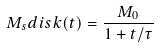Convert formula to latex. <formula><loc_0><loc_0><loc_500><loc_500>M _ { s } { d i s k } ( t ) = \frac { M _ { 0 } } { 1 + t / \tau }</formula> 